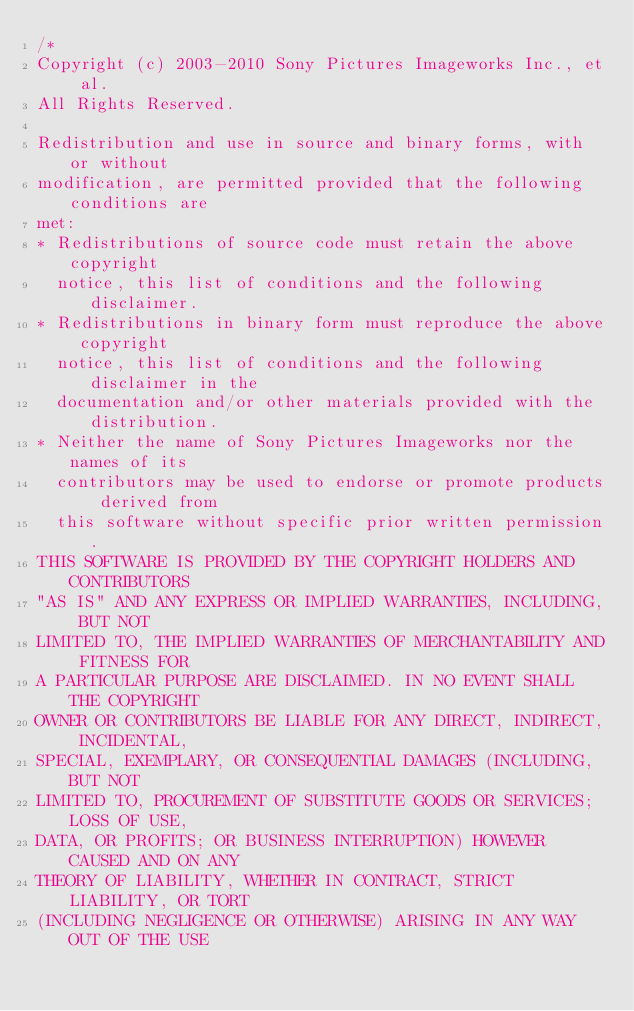Convert code to text. <code><loc_0><loc_0><loc_500><loc_500><_C++_>/*
Copyright (c) 2003-2010 Sony Pictures Imageworks Inc., et al.
All Rights Reserved.

Redistribution and use in source and binary forms, with or without
modification, are permitted provided that the following conditions are
met:
* Redistributions of source code must retain the above copyright
  notice, this list of conditions and the following disclaimer.
* Redistributions in binary form must reproduce the above copyright
  notice, this list of conditions and the following disclaimer in the
  documentation and/or other materials provided with the distribution.
* Neither the name of Sony Pictures Imageworks nor the names of its
  contributors may be used to endorse or promote products derived from
  this software without specific prior written permission.
THIS SOFTWARE IS PROVIDED BY THE COPYRIGHT HOLDERS AND CONTRIBUTORS
"AS IS" AND ANY EXPRESS OR IMPLIED WARRANTIES, INCLUDING, BUT NOT
LIMITED TO, THE IMPLIED WARRANTIES OF MERCHANTABILITY AND FITNESS FOR
A PARTICULAR PURPOSE ARE DISCLAIMED. IN NO EVENT SHALL THE COPYRIGHT
OWNER OR CONTRIBUTORS BE LIABLE FOR ANY DIRECT, INDIRECT, INCIDENTAL,
SPECIAL, EXEMPLARY, OR CONSEQUENTIAL DAMAGES (INCLUDING, BUT NOT
LIMITED TO, PROCUREMENT OF SUBSTITUTE GOODS OR SERVICES; LOSS OF USE,
DATA, OR PROFITS; OR BUSINESS INTERRUPTION) HOWEVER CAUSED AND ON ANY
THEORY OF LIABILITY, WHETHER IN CONTRACT, STRICT LIABILITY, OR TORT
(INCLUDING NEGLIGENCE OR OTHERWISE) ARISING IN ANY WAY OUT OF THE USE</code> 